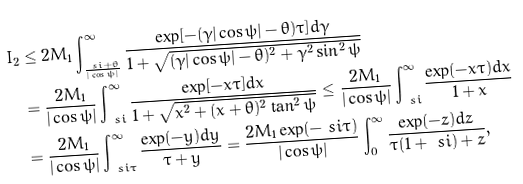<formula> <loc_0><loc_0><loc_500><loc_500>I _ { 2 } & \leq 2 M _ { 1 } \int _ { \frac { \ s i + \theta } { | \cos \psi | } } ^ { \infty } \frac { \exp [ - ( \gamma | \cos \psi | - \theta ) \tau ] d \gamma } { 1 + \sqrt { ( \gamma | \cos \psi | - \theta ) ^ { 2 } + \gamma ^ { 2 } \sin ^ { 2 } \psi } } \\ & = \frac { 2 M _ { 1 } } { | \cos \psi | } \int _ { \ s i } ^ { \infty } \frac { \exp [ - x \tau ] d x } { 1 + \sqrt { x ^ { 2 } + ( x + \theta ) ^ { 2 } \tan ^ { 2 } \psi } } \leq \frac { 2 M _ { 1 } } { | \cos \psi | } \int _ { \ s i } ^ { \infty } \frac { \exp ( - x \tau ) d x } { 1 + x } \\ & = \frac { 2 M _ { 1 } } { | \cos \psi | } \int _ { \ s i \tau } ^ { \infty } \frac { \exp ( - y ) d y } { \tau + y } = \frac { 2 M _ { 1 } \exp ( - \ s i \tau ) } { | \cos \psi | } \int _ { 0 } ^ { \infty } \frac { \exp ( - z ) d z } { \tau ( 1 + \ s i ) + z } ,</formula> 